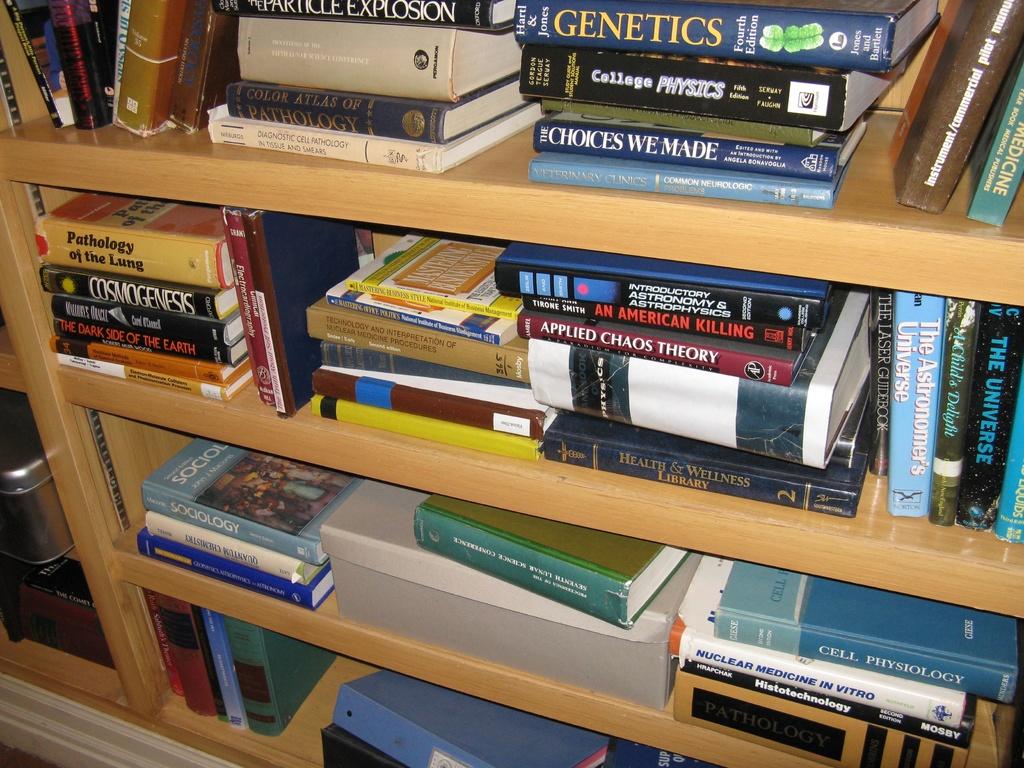Are these books about human biology?
Provide a succinct answer. Yes. What is the top book about?
Make the answer very short. Genetics. 